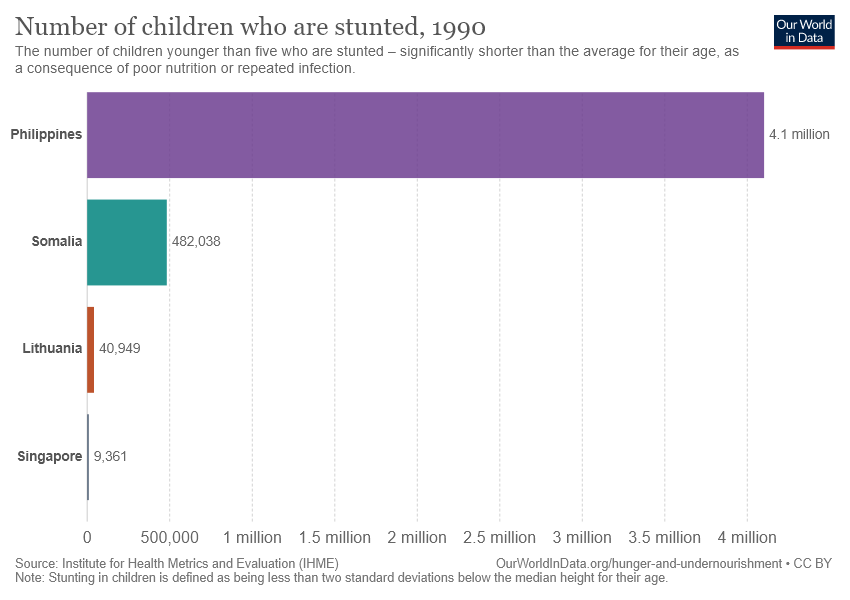Give some essential details in this illustration. The value of Somalia is greater than that of Lithuania and Singapore. The grey bar represents Singapore in the given map. 